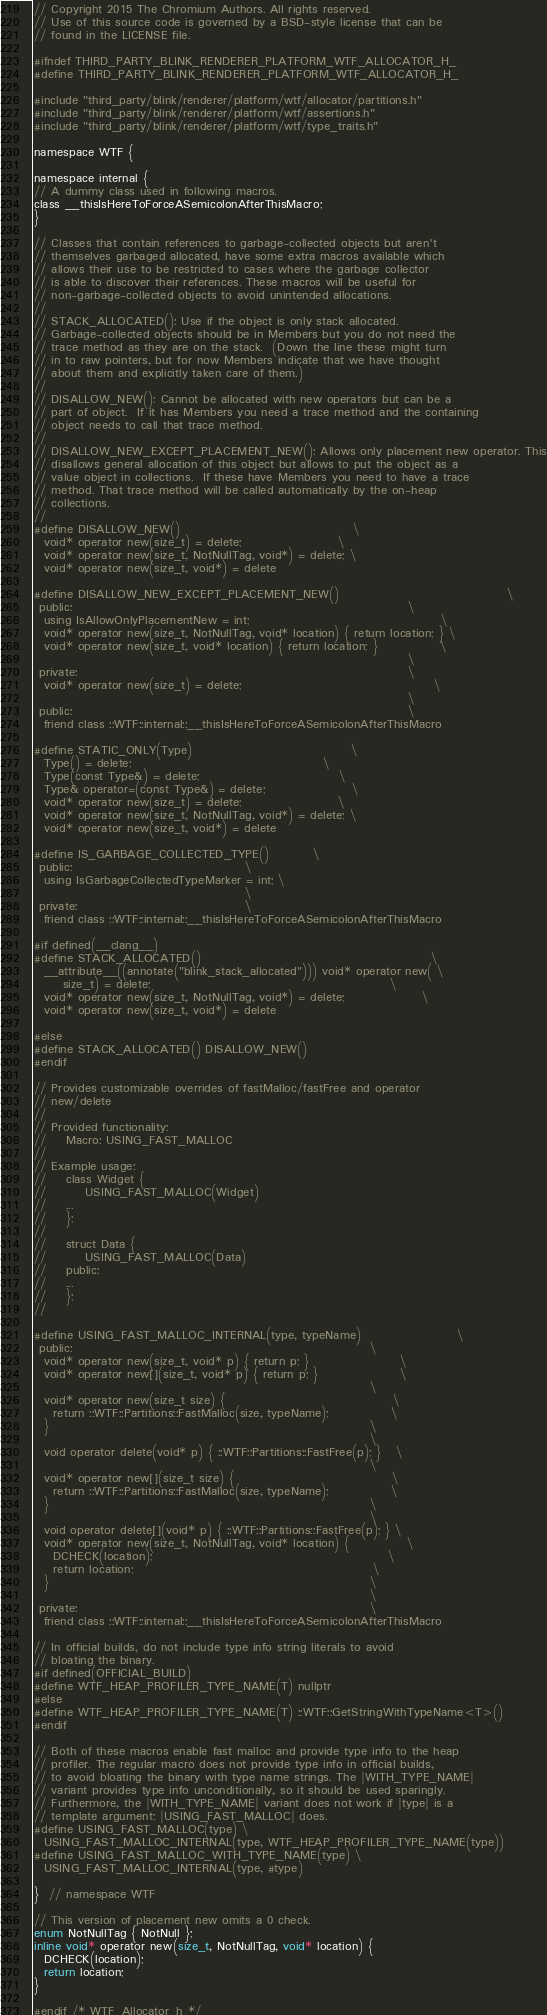<code> <loc_0><loc_0><loc_500><loc_500><_C_>// Copyright 2015 The Chromium Authors. All rights reserved.
// Use of this source code is governed by a BSD-style license that can be
// found in the LICENSE file.

#ifndef THIRD_PARTY_BLINK_RENDERER_PLATFORM_WTF_ALLOCATOR_H_
#define THIRD_PARTY_BLINK_RENDERER_PLATFORM_WTF_ALLOCATOR_H_

#include "third_party/blink/renderer/platform/wtf/allocator/partitions.h"
#include "third_party/blink/renderer/platform/wtf/assertions.h"
#include "third_party/blink/renderer/platform/wtf/type_traits.h"

namespace WTF {

namespace internal {
// A dummy class used in following macros.
class __thisIsHereToForceASemicolonAfterThisMacro;
}

// Classes that contain references to garbage-collected objects but aren't
// themselves garbaged allocated, have some extra macros available which
// allows their use to be restricted to cases where the garbage collector
// is able to discover their references. These macros will be useful for
// non-garbage-collected objects to avoid unintended allocations.
//
// STACK_ALLOCATED(): Use if the object is only stack allocated.
// Garbage-collected objects should be in Members but you do not need the
// trace method as they are on the stack.  (Down the line these might turn
// in to raw pointers, but for now Members indicate that we have thought
// about them and explicitly taken care of them.)
//
// DISALLOW_NEW(): Cannot be allocated with new operators but can be a
// part of object.  If it has Members you need a trace method and the containing
// object needs to call that trace method.
//
// DISALLOW_NEW_EXCEPT_PLACEMENT_NEW(): Allows only placement new operator. This
// disallows general allocation of this object but allows to put the object as a
// value object in collections.  If these have Members you need to have a trace
// method. That trace method will be called automatically by the on-heap
// collections.
//
#define DISALLOW_NEW()                                    \
  void* operator new(size_t) = delete;                    \
  void* operator new(size_t, NotNullTag, void*) = delete; \
  void* operator new(size_t, void*) = delete

#define DISALLOW_NEW_EXCEPT_PLACEMENT_NEW()                                   \
 public:                                                                      \
  using IsAllowOnlyPlacementNew = int;                                        \
  void* operator new(size_t, NotNullTag, void* location) { return location; } \
  void* operator new(size_t, void* location) { return location; }             \
                                                                              \
 private:                                                                     \
  void* operator new(size_t) = delete;                                        \
                                                                              \
 public:                                                                      \
  friend class ::WTF::internal::__thisIsHereToForceASemicolonAfterThisMacro

#define STATIC_ONLY(Type)                                 \
  Type() = delete;                                        \
  Type(const Type&) = delete;                             \
  Type& operator=(const Type&) = delete;                  \
  void* operator new(size_t) = delete;                    \
  void* operator new(size_t, NotNullTag, void*) = delete; \
  void* operator new(size_t, void*) = delete

#define IS_GARBAGE_COLLECTED_TYPE()         \
 public:                                    \
  using IsGarbageCollectedTypeMarker = int; \
                                            \
 private:                                   \
  friend class ::WTF::internal::__thisIsHereToForceASemicolonAfterThisMacro

#if defined(__clang__)
#define STACK_ALLOCATED()                                                \
  __attribute__((annotate("blink_stack_allocated"))) void* operator new( \
      size_t) = delete;                                                  \
  void* operator new(size_t, NotNullTag, void*) = delete;                \
  void* operator new(size_t, void*) = delete

#else
#define STACK_ALLOCATED() DISALLOW_NEW()
#endif

// Provides customizable overrides of fastMalloc/fastFree and operator
// new/delete
//
// Provided functionality:
//    Macro: USING_FAST_MALLOC
//
// Example usage:
//    class Widget {
//        USING_FAST_MALLOC(Widget)
//    ...
//    };
//
//    struct Data {
//        USING_FAST_MALLOC(Data)
//    public:
//    ...
//    };
//

#define USING_FAST_MALLOC_INTERNAL(type, typeName)                    \
 public:                                                              \
  void* operator new(size_t, void* p) { return p; }                   \
  void* operator new[](size_t, void* p) { return p; }                 \
                                                                      \
  void* operator new(size_t size) {                                   \
    return ::WTF::Partitions::FastMalloc(size, typeName);             \
  }                                                                   \
                                                                      \
  void operator delete(void* p) { ::WTF::Partitions::FastFree(p); }   \
                                                                      \
  void* operator new[](size_t size) {                                 \
    return ::WTF::Partitions::FastMalloc(size, typeName);             \
  }                                                                   \
                                                                      \
  void operator delete[](void* p) { ::WTF::Partitions::FastFree(p); } \
  void* operator new(size_t, NotNullTag, void* location) {            \
    DCHECK(location);                                                 \
    return location;                                                  \
  }                                                                   \
                                                                      \
 private:                                                             \
  friend class ::WTF::internal::__thisIsHereToForceASemicolonAfterThisMacro

// In official builds, do not include type info string literals to avoid
// bloating the binary.
#if defined(OFFICIAL_BUILD)
#define WTF_HEAP_PROFILER_TYPE_NAME(T) nullptr
#else
#define WTF_HEAP_PROFILER_TYPE_NAME(T) ::WTF::GetStringWithTypeName<T>()
#endif

// Both of these macros enable fast malloc and provide type info to the heap
// profiler. The regular macro does not provide type info in official builds,
// to avoid bloating the binary with type name strings. The |WITH_TYPE_NAME|
// variant provides type info unconditionally, so it should be used sparingly.
// Furthermore, the |WITH_TYPE_NAME| variant does not work if |type| is a
// template argument; |USING_FAST_MALLOC| does.
#define USING_FAST_MALLOC(type) \
  USING_FAST_MALLOC_INTERNAL(type, WTF_HEAP_PROFILER_TYPE_NAME(type))
#define USING_FAST_MALLOC_WITH_TYPE_NAME(type) \
  USING_FAST_MALLOC_INTERNAL(type, #type)

}  // namespace WTF

// This version of placement new omits a 0 check.
enum NotNullTag { NotNull };
inline void* operator new(size_t, NotNullTag, void* location) {
  DCHECK(location);
  return location;
}

#endif /* WTF_Allocator_h */
</code> 